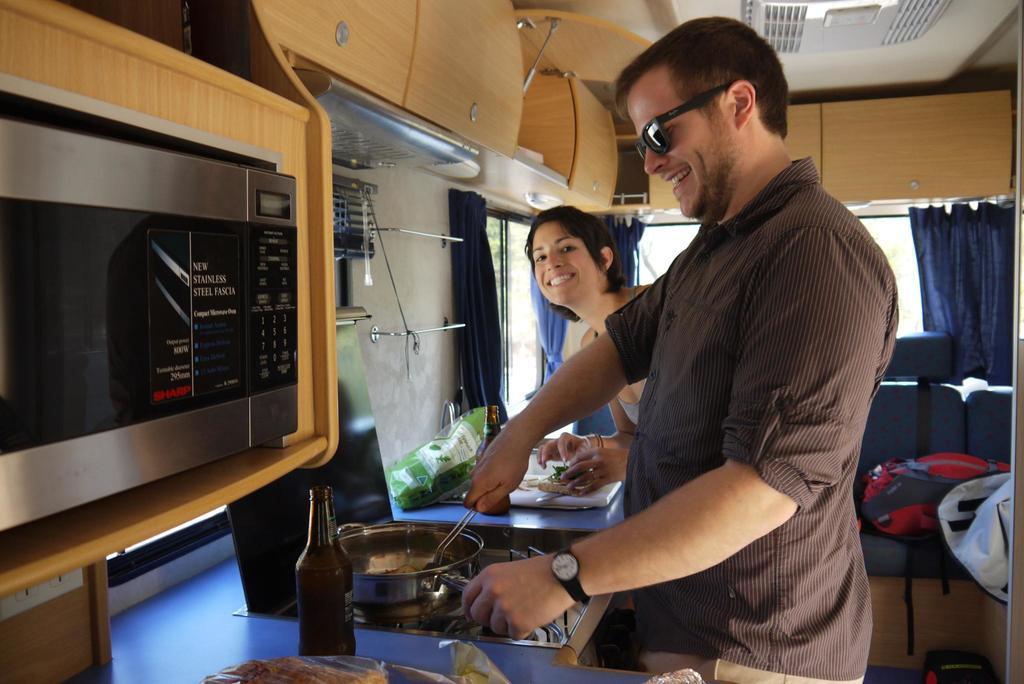What is written on the microwave?
Offer a very short reply. New stainless steel fascia. 